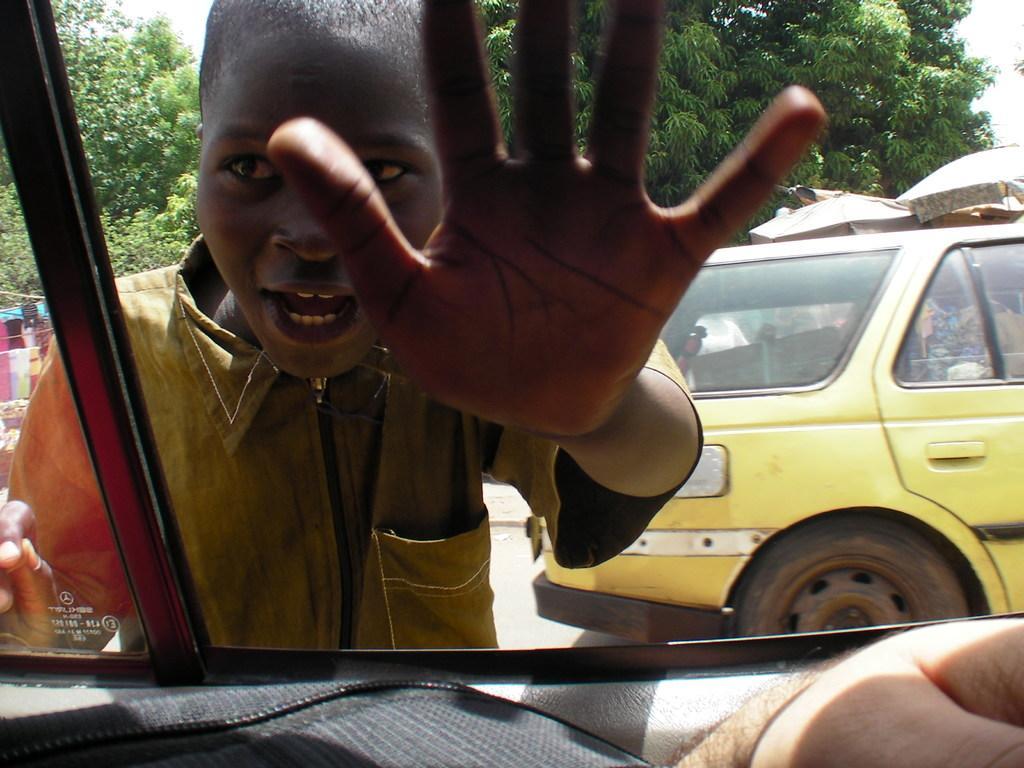Describe this image in one or two sentences. In this image we can see a person placed his hand to the mirror of a vehicle. In the vehicle there is another person. On the right side of the image there is a vehicle on the road. In the background there are trees. 